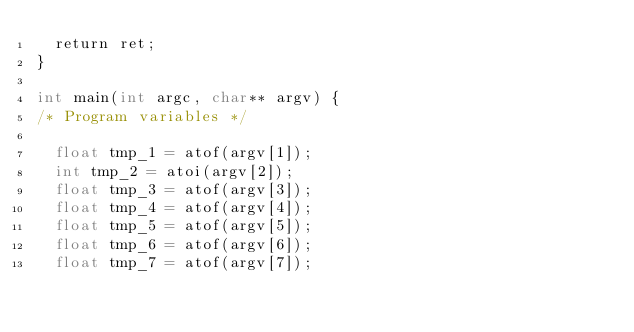Convert code to text. <code><loc_0><loc_0><loc_500><loc_500><_Cuda_>  return ret;
}

int main(int argc, char** argv) {
/* Program variables */

  float tmp_1 = atof(argv[1]);
  int tmp_2 = atoi(argv[2]);
  float tmp_3 = atof(argv[3]);
  float tmp_4 = atof(argv[4]);
  float tmp_5 = atof(argv[5]);
  float tmp_6 = atof(argv[6]);
  float tmp_7 = atof(argv[7]);</code> 